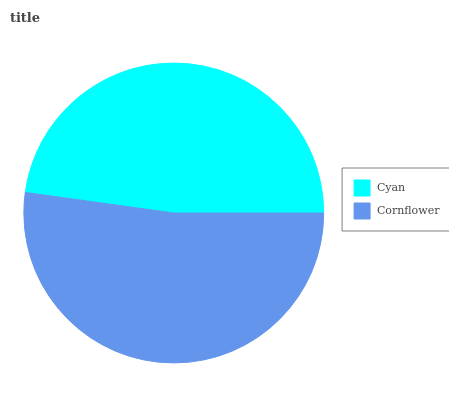Is Cyan the minimum?
Answer yes or no. Yes. Is Cornflower the maximum?
Answer yes or no. Yes. Is Cornflower the minimum?
Answer yes or no. No. Is Cornflower greater than Cyan?
Answer yes or no. Yes. Is Cyan less than Cornflower?
Answer yes or no. Yes. Is Cyan greater than Cornflower?
Answer yes or no. No. Is Cornflower less than Cyan?
Answer yes or no. No. Is Cornflower the high median?
Answer yes or no. Yes. Is Cyan the low median?
Answer yes or no. Yes. Is Cyan the high median?
Answer yes or no. No. Is Cornflower the low median?
Answer yes or no. No. 